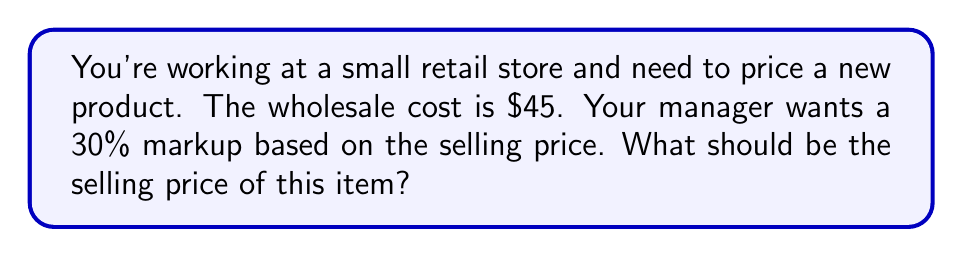Provide a solution to this math problem. Let's approach this step-by-step:

1) Let $x$ be the selling price.

2) The markup is 30% of the selling price, which means the cost ($45) is 70% of the selling price.

3) We can express this as an equation:
   
   $45 = 0.70x$

4) To solve for $x$, divide both sides by 0.70:
   
   $\frac{45}{0.70} = x$

5) Calculate:
   
   $x = 64.2857...$

6) Round to the nearest cent:
   
   $x = $64.29

This means the selling price should be $64.29 to achieve a 30% markup based on the selling price.

To verify:
- Cost: $45
- Markup: $64.29 - $45 = $19.29
- Markup percentage: $\frac{19.29}{64.29} \approx 0.30$ or 30%
Answer: $64.29 